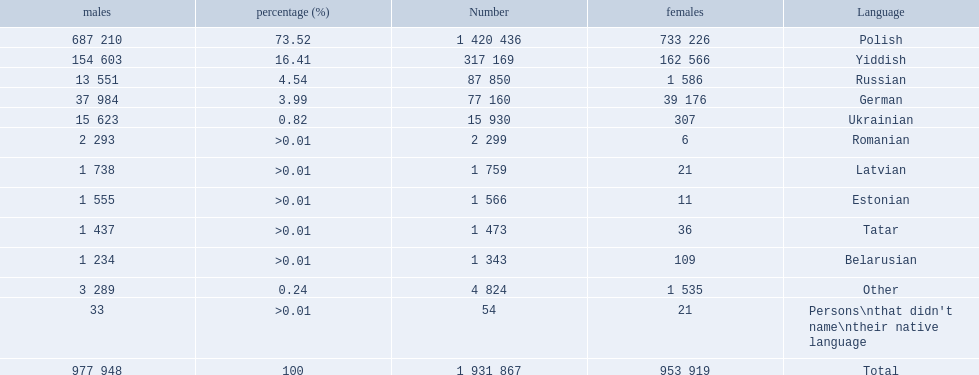Which languages are spoken by more than 50,000 people? Polish, Yiddish, Russian, German. Of these languages, which ones are spoken by less than 15% of the population? Russian, German. Of the remaining two, which one is spoken by 37,984 males? German. 